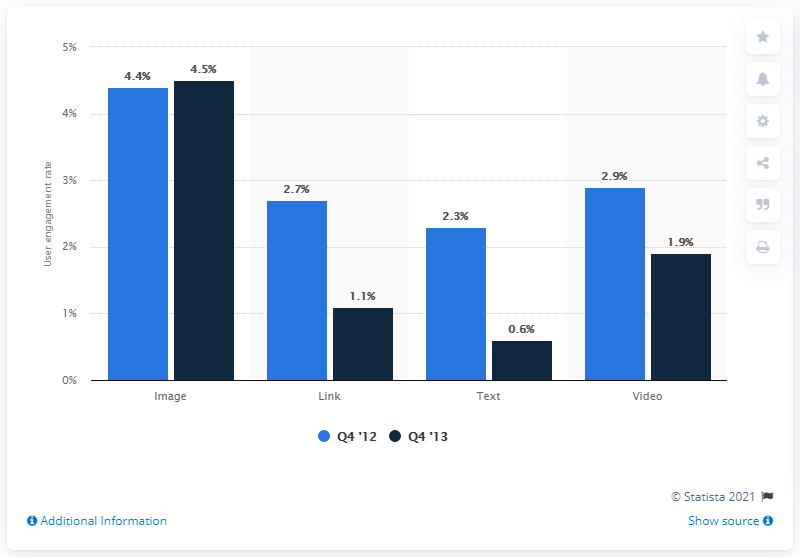Highlight a few significant elements in this photo. During the fourth quarter of 2012, the difference in percentage between text and video was 0.6%. In Q4 '13, the navy blue color indicates a particular meaning or significance. In the fourth quarter of 2013, the engagement rate of brand posts on Facebook was 4.5%. 